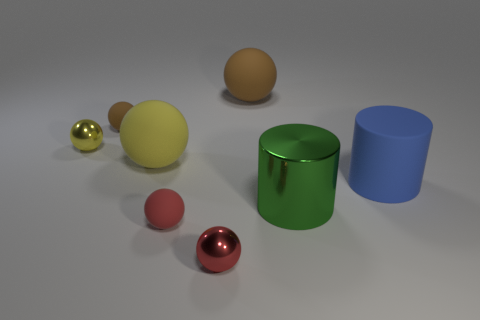Subtract all red balls. How many balls are left? 4 Add 1 blue shiny balls. How many objects exist? 9 Subtract all brown spheres. Subtract all blue cylinders. How many spheres are left? 4 Subtract all red metallic balls. How many balls are left? 5 Subtract all balls. How many objects are left? 2 Subtract all tiny brown spheres. Subtract all large metallic spheres. How many objects are left? 7 Add 3 red shiny balls. How many red shiny balls are left? 4 Add 8 red things. How many red things exist? 10 Subtract 0 red cubes. How many objects are left? 8 